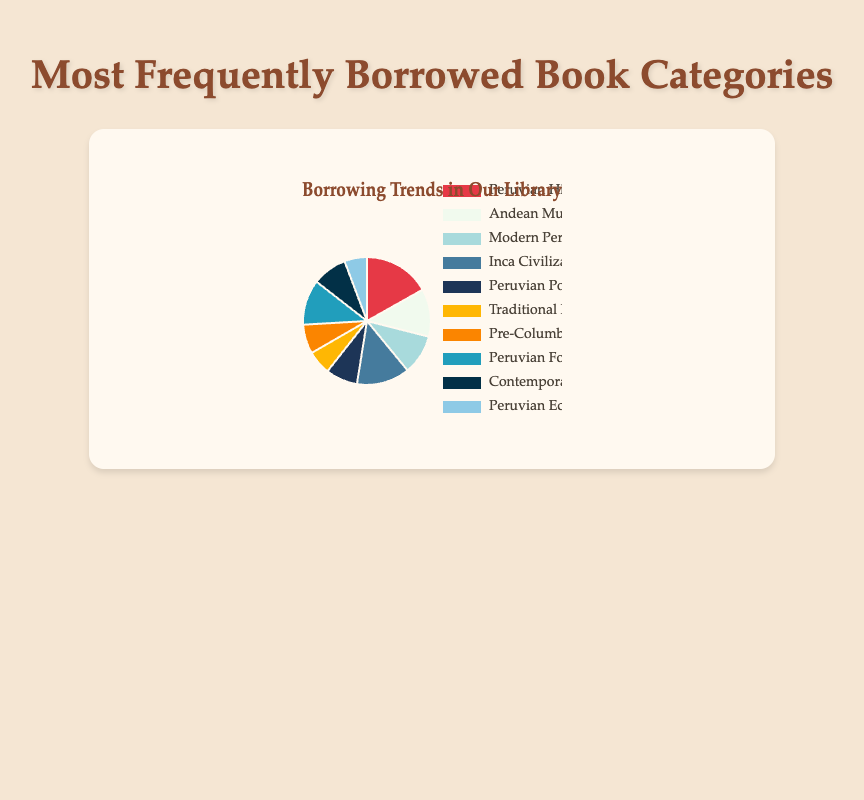Which book category is borrowed the most in our library? From the pie chart, the largest slice represents "Peruvian History" with 250 borrowed books.
Answer: Peruvian History Which book category is borrowed the least in our library? The smallest slice in the pie chart represents "Peruvian Economic History" with 85 borrowed books.
Answer: Peruvian Economic History How many total books are borrowed in the categories "Andean Music" and "Peruvian Folklore"? The number of borrowed books for "Andean Music" is 180 and for "Peruvian Folklore" is 170. Summing them up gives 180 + 170 = 350.
Answer: 350 Is "Inca Civilization" more popular than "Modern Peruvian Literature"? The borrowed count for "Inca Civilization" is 200, while for "Modern Peruvian Literature," it is 150. Since 200 is greater than 150, "Inca Civilization" is more popular.
Answer: Yes Which book category is represented by a red slice? Looking at the colors of the slices and their labels, the red slice corresponds to "Peruvian History."
Answer: Peruvian History What is the combined number of books borrowed in "Traditional Peruvian Recipes", "Pre-Columbian Art", and "Contemporary Peruvian Authors"? The borrowed count for "Traditional Peruvian Recipes" is 90, for "Pre-Columbian Art" is 110, and for "Contemporary Peruvian Authors" is 130. Adding these together gives 90 + 110 + 130 = 330.
Answer: 330 Which category is more popular: "Peruvian Poetry" or "Pre-Columbian Art"? The borrowed count for "Peruvian Poetry" is 120 and for "Pre-Columbian Art" is 110. Since 120 is greater than 110, "Peruvian Poetry" is more popular.
Answer: Peruvian Poetry What is the difference in borrowed count between the most and least popular categories? The most popular category is "Peruvian History" with 250 books borrowed, and the least popular is "Peruvian Economic History" with 85 books borrowed. The difference is 250 - 85 = 165.
Answer: 165 How many book categories have a borrowed count of more than 150? The categories with more than 150 borrowed books are "Peruvian History" (250), "Andean Music" (180), "Inca Civilization" (200), and "Peruvian Folklore" (170). There are 4 such categories.
Answer: 4 